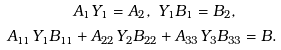<formula> <loc_0><loc_0><loc_500><loc_500>& A _ { 1 } Y _ { 1 } = A _ { 2 } , \ Y _ { 1 } B _ { 1 } = B _ { 2 } , \\ A _ { 1 1 } Y _ { 1 } B _ { 1 1 } & + A _ { 2 2 } Y _ { 2 } B _ { 2 2 } + A _ { 3 3 } Y _ { 3 } B _ { 3 3 } = B .</formula> 